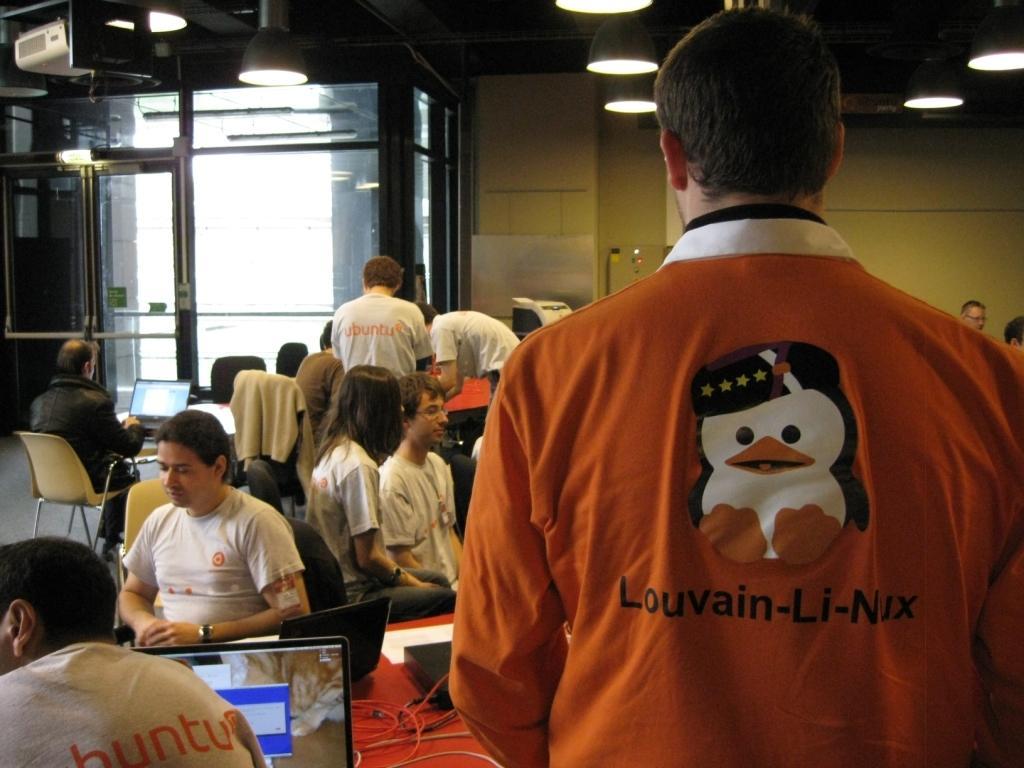Can you describe this image briefly? In this image there are group of people who are sitting and in the right side of the image there is one person who is standing and there are some chairs. In the left side of the middle of the image there is one person who is wearing black jacket is sitting on a chair and he is looking at laptop and on the top of the image there is one wall and on ceiling there are some lights and on the left side there is one window. 